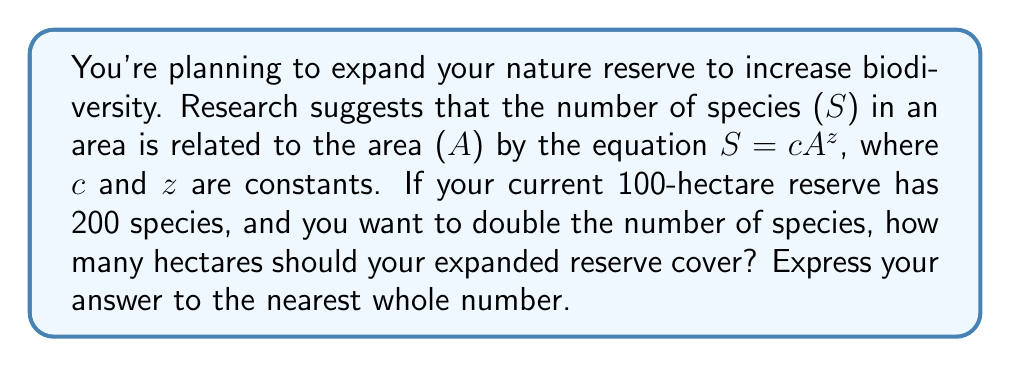Show me your answer to this math problem. Let's approach this step-by-step:

1) We're given the species-area relationship: $S = cA^z$

2) For the current reserve:
   $200 = c(100)^z$

3) For the expanded reserve, we want to double the species:
   $400 = cA^z$, where A is the new area we're solving for

4) Dividing these equations:
   $\frac{400}{200} = \frac{cA^z}{c(100)^z}$

5) The c's cancel out:
   $2 = (\frac{A}{100})^z$

6) Taking the logarithm of both sides:
   $\log 2 = z \log (\frac{A}{100})$

7) Rearranging:
   $\frac{\log 2}{z} = \log (\frac{A}{100})$

8) Exponentiating both sides:
   $2^{\frac{1}{z}} = \frac{A}{100}$

9) Solving for A:
   $A = 100 \cdot 2^{\frac{1}{z}}$

10) Typical z values for terrestrial ecosystems range from 0.20 to 0.35. Let's use z = 0.25 as an average:
    $A = 100 \cdot 2^{\frac{1}{0.25}} = 100 \cdot 2^4 = 1600$

Therefore, the expanded reserve should cover approximately 1600 hectares.
Answer: 1600 hectares 